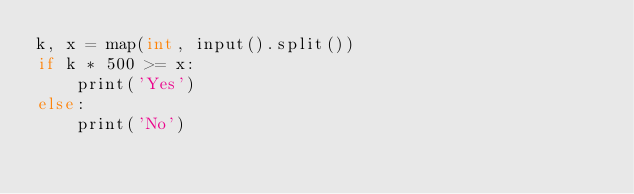Convert code to text. <code><loc_0><loc_0><loc_500><loc_500><_Java_>k, x = map(int, input().split())
if k * 500 >= x:
    print('Yes')
else:
    print('No')</code> 